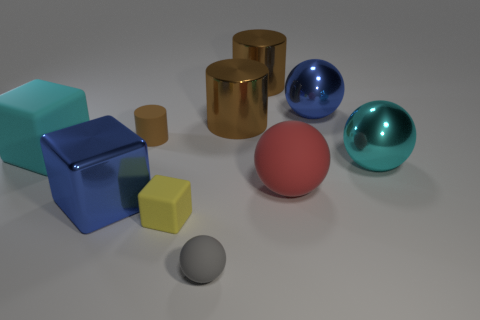What number of cubes are either gray things or large things? Observing the image, there are a total of two cubes that fit the criteria: one is a large, cyan-colored cube, and the other is a smaller, gray cube. If we include all objects that are either gray or large regardless of shape, we have five such objects: one large cyan cube, one large blue cube, one large gold cylinder, one small gray cube, and one small gray sphere. 